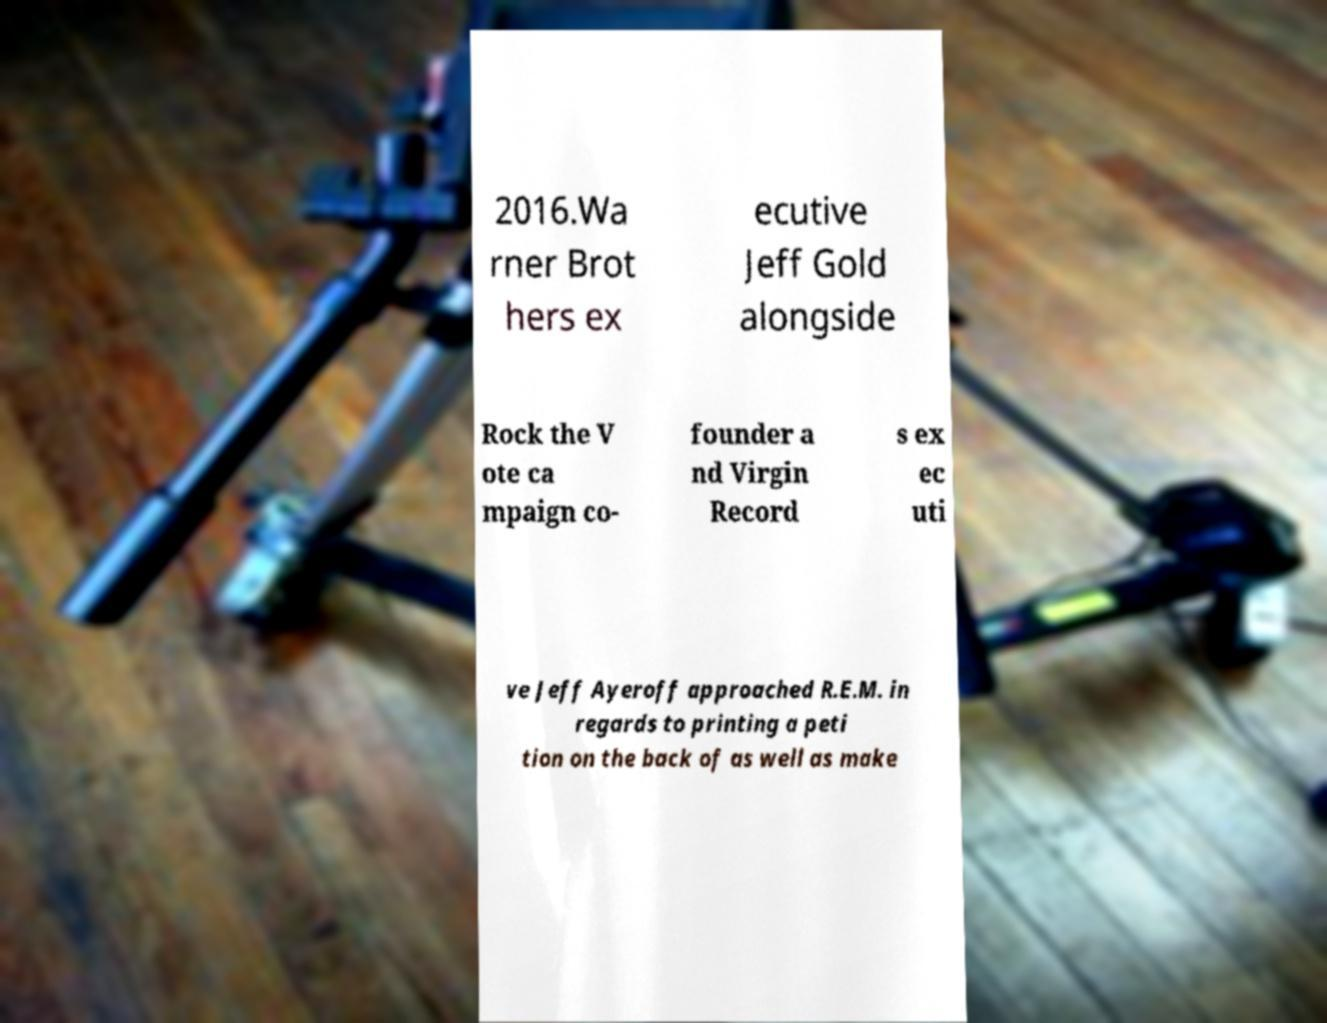There's text embedded in this image that I need extracted. Can you transcribe it verbatim? 2016.Wa rner Brot hers ex ecutive Jeff Gold alongside Rock the V ote ca mpaign co- founder a nd Virgin Record s ex ec uti ve Jeff Ayeroff approached R.E.M. in regards to printing a peti tion on the back of as well as make 